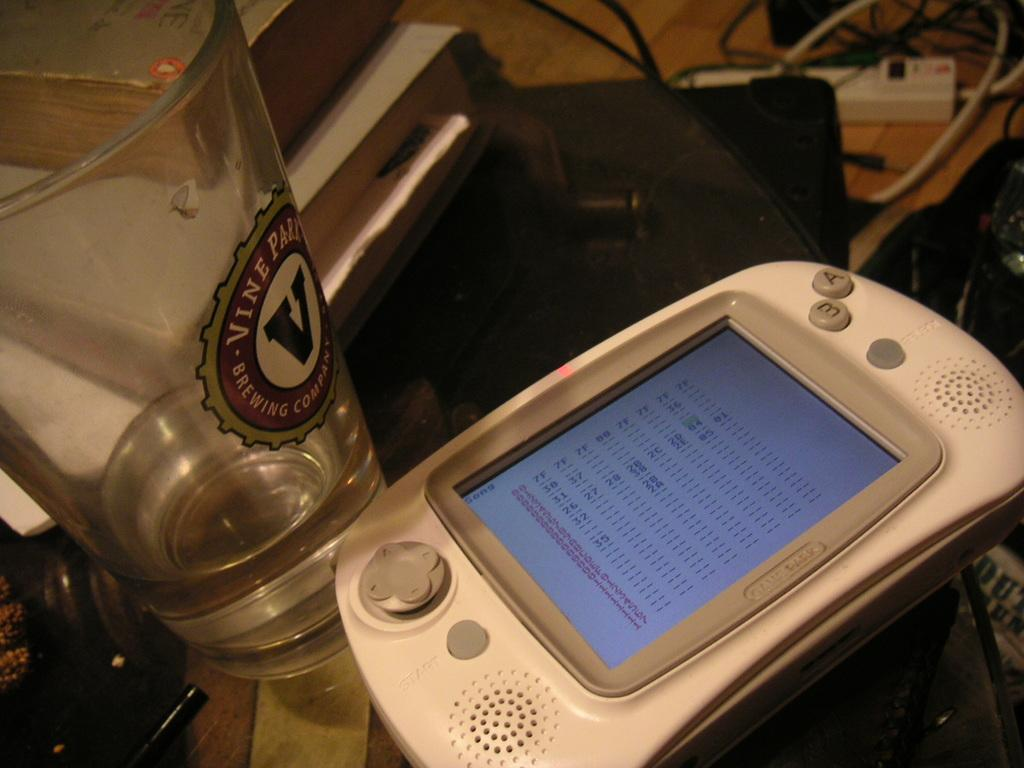Provide a one-sentence caption for the provided image. A handheld device on a table with a Vine Park Brewing Company glass. 